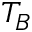Convert formula to latex. <formula><loc_0><loc_0><loc_500><loc_500>T _ { B }</formula> 